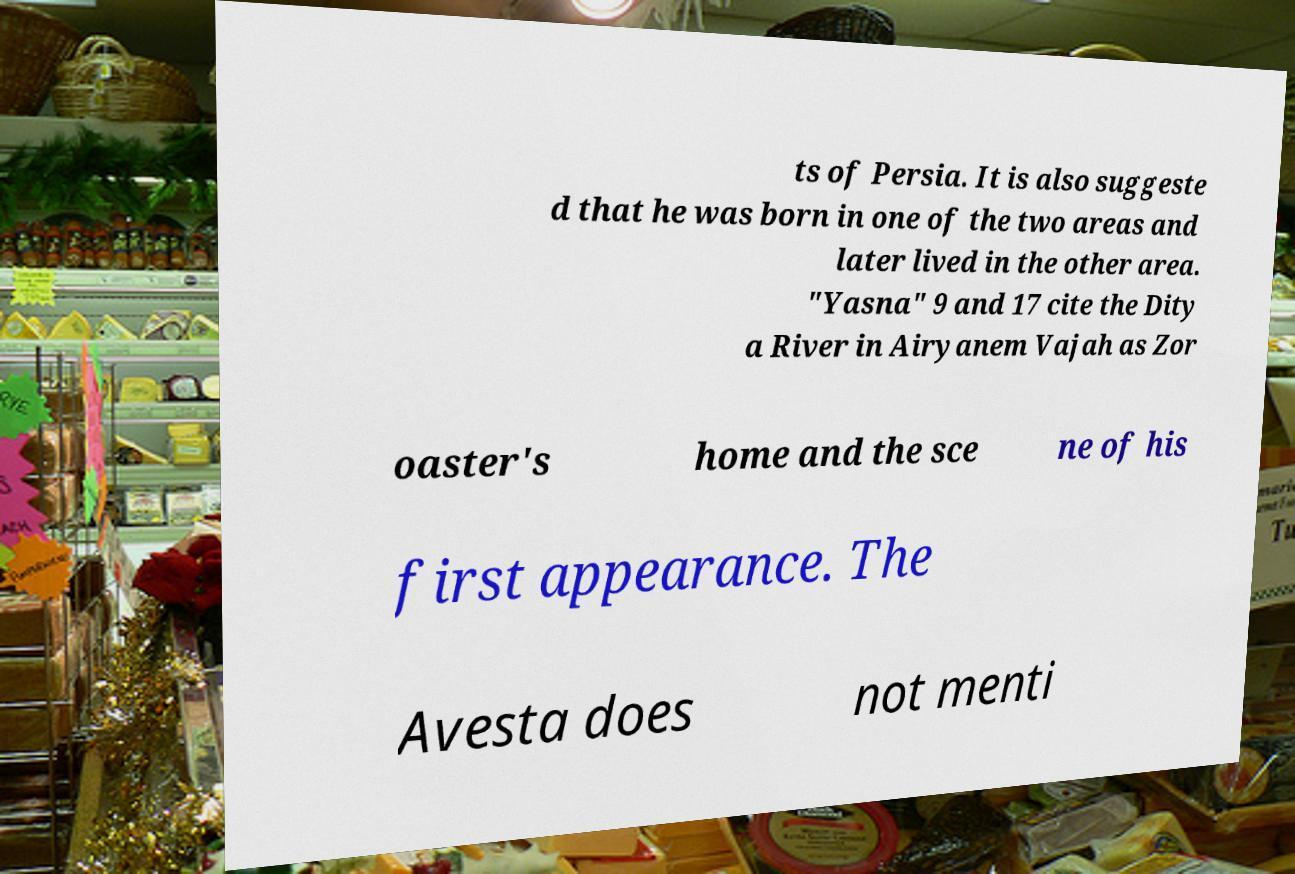For documentation purposes, I need the text within this image transcribed. Could you provide that? ts of Persia. It is also suggeste d that he was born in one of the two areas and later lived in the other area. "Yasna" 9 and 17 cite the Dity a River in Airyanem Vajah as Zor oaster's home and the sce ne of his first appearance. The Avesta does not menti 